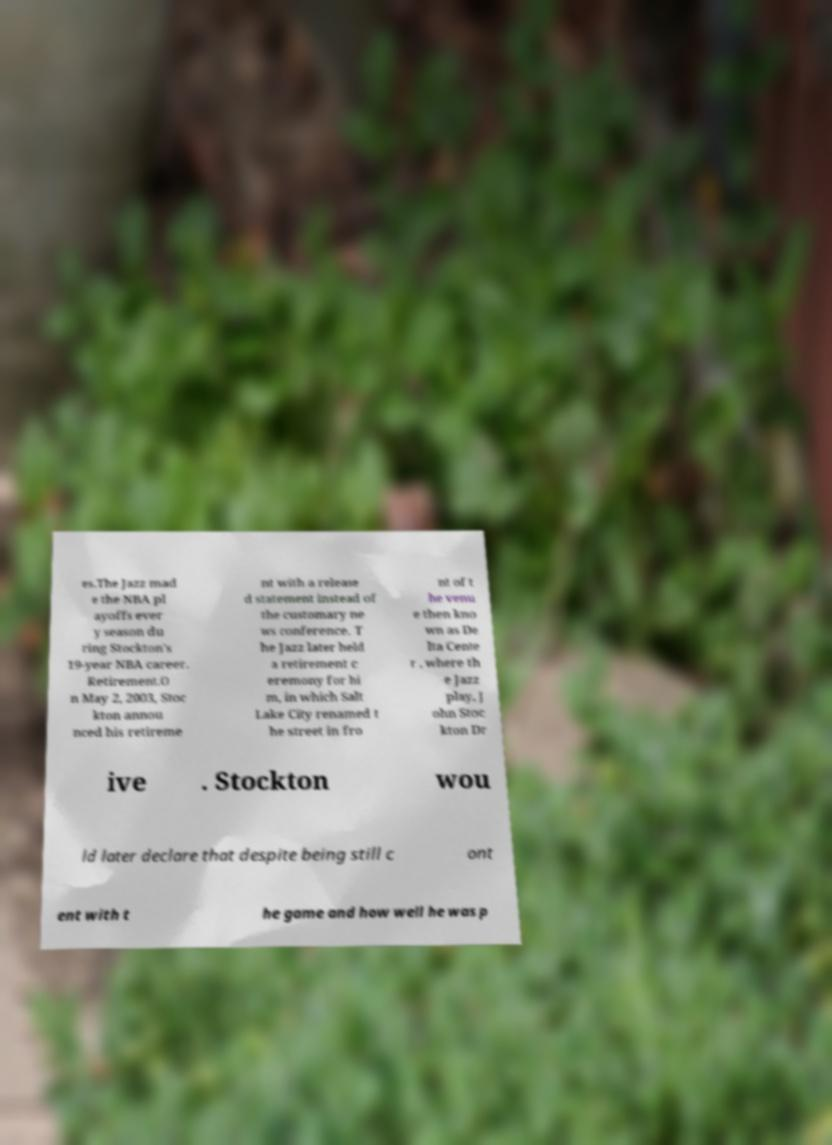Can you accurately transcribe the text from the provided image for me? es.The Jazz mad e the NBA pl ayoffs ever y season du ring Stockton's 19-year NBA career. Retirement.O n May 2, 2003, Stoc kton annou nced his retireme nt with a release d statement instead of the customary ne ws conference. T he Jazz later held a retirement c eremony for hi m, in which Salt Lake City renamed t he street in fro nt of t he venu e then kno wn as De lta Cente r , where th e Jazz play, J ohn Stoc kton Dr ive . Stockton wou ld later declare that despite being still c ont ent with t he game and how well he was p 